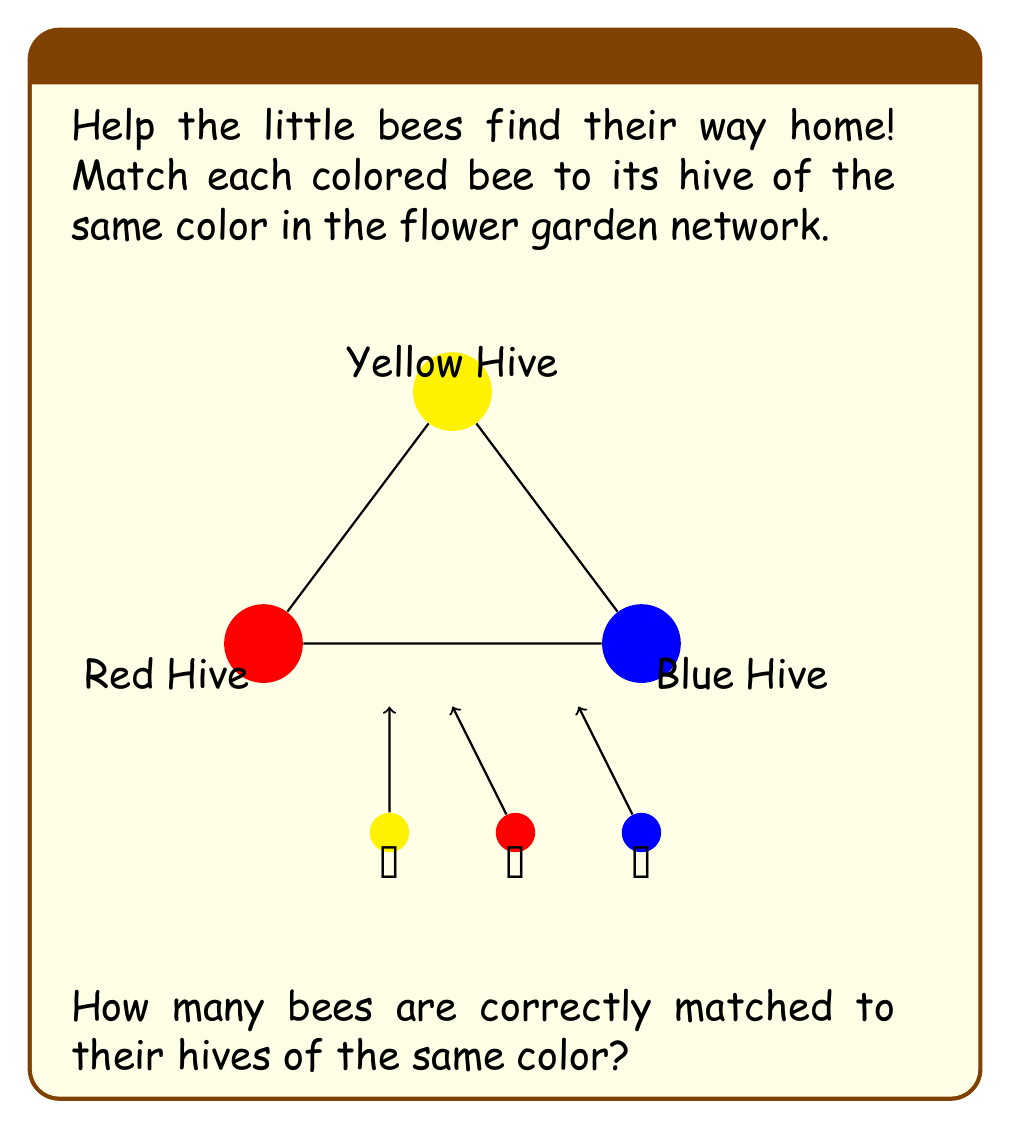Provide a solution to this math problem. Let's match each bee to its corresponding hive step by step:

1. Yellow bee:
   - The yellow bee is at the bottom left.
   - The yellow hive is at the top of the triangle.
   - The yellow bee is correctly matched to its hive.

2. Red bee:
   - The red bee is in the middle at the bottom.
   - The red hive is at the bottom left of the triangle.
   - The red bee is correctly matched to its hive.

3. Blue bee:
   - The blue bee is at the bottom right.
   - The blue hive is at the bottom right of the triangle.
   - The blue bee is correctly matched to its hive.

Counting the correctly matched bees:
$$ \text{Correctly matched bees} = 1 + 1 + 1 = 3 $$

Therefore, all three bees are correctly matched to their hives of the same color.
Answer: 3 